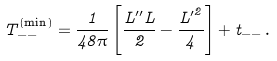<formula> <loc_0><loc_0><loc_500><loc_500>T _ { - - } ^ { \left ( \min \right ) } = \frac { 1 } { 4 8 \pi } \left [ \frac { L ^ { \prime \prime } L } { 2 } - \frac { { L ^ { \prime } } ^ { 2 } } { 4 } \right ] + t _ { - - } \, .</formula> 